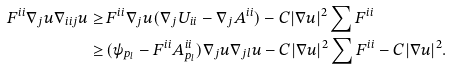Convert formula to latex. <formula><loc_0><loc_0><loc_500><loc_500>F ^ { i i } \nabla _ { j } u \nabla _ { i i j } u \geq \, & F ^ { i i } \nabla _ { j } u ( \nabla _ { j } U _ { i i } - \nabla _ { j } A ^ { i i } ) - C | \nabla u | ^ { 2 } \sum F ^ { i i } \\ \geq \, & ( \psi _ { p _ { l } } - F ^ { i i } A ^ { i i } _ { p _ { l } } ) \nabla _ { j } u \nabla _ { j l } u - C | \nabla u | ^ { 2 } \sum F ^ { i i } - C | \nabla u | ^ { 2 } .</formula> 